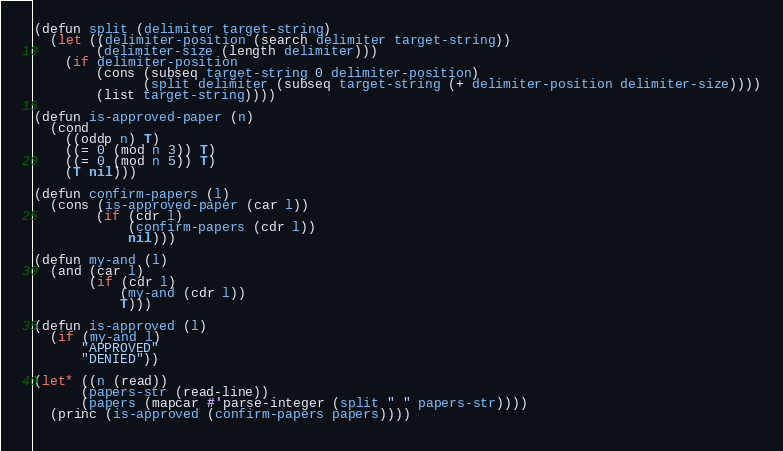Convert code to text. <code><loc_0><loc_0><loc_500><loc_500><_Lisp_>(defun split (delimiter target-string)
  (let ((delimiter-position (search delimiter target-string))
        (delimiter-size (length delimiter)))
    (if delimiter-position
        (cons (subseq target-string 0 delimiter-position)
              (split delimiter (subseq target-string (+ delimiter-position delimiter-size))))
        (list target-string))))

(defun is-approved-paper (n)
  (cond
    ((oddp n) T)
    ((= 0 (mod n 3)) T)
    ((= 0 (mod n 5)) T)
    (T nil)))

(defun confirm-papers (l)
  (cons (is-approved-paper (car l))
        (if (cdr l)
            (confirm-papers (cdr l))
            nil)))

(defun my-and (l)
  (and (car l)
       (if (cdr l)
           (my-and (cdr l))
           T)))

(defun is-approved (l)
  (if (my-and l)
      "APPROVED"
      "DENIED"))

(let* ((n (read))
      (papers-str (read-line))
      (papers (mapcar #'parse-integer (split " " papers-str))))
  (princ (is-approved (confirm-papers papers))))
  
</code> 